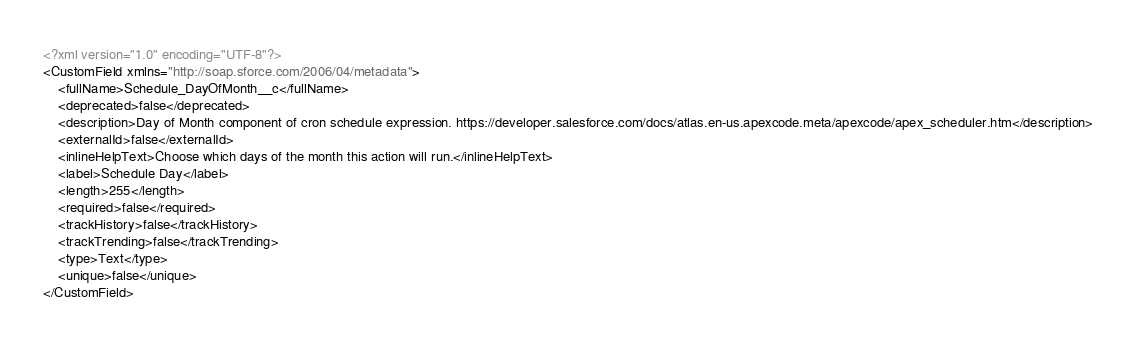<code> <loc_0><loc_0><loc_500><loc_500><_XML_><?xml version="1.0" encoding="UTF-8"?>
<CustomField xmlns="http://soap.sforce.com/2006/04/metadata">
    <fullName>Schedule_DayOfMonth__c</fullName>
    <deprecated>false</deprecated>
    <description>Day of Month component of cron schedule expression. https://developer.salesforce.com/docs/atlas.en-us.apexcode.meta/apexcode/apex_scheduler.htm</description>
    <externalId>false</externalId>
    <inlineHelpText>Choose which days of the month this action will run.</inlineHelpText>
    <label>Schedule Day</label>
    <length>255</length>
    <required>false</required>
    <trackHistory>false</trackHistory>
    <trackTrending>false</trackTrending>
    <type>Text</type>
    <unique>false</unique>
</CustomField>
</code> 